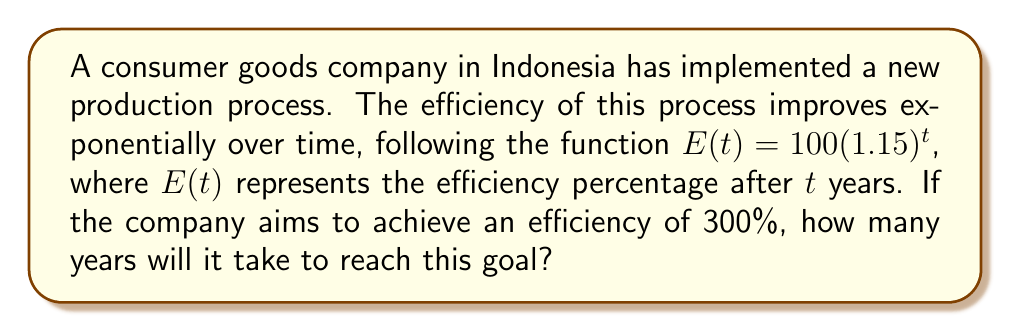Help me with this question. To solve this problem, we need to use the exponential function given and solve for $t$ when $E(t) = 300$. Let's approach this step-by-step:

1) We start with the equation: $E(t) = 100(1.15)^t$

2) We want to find $t$ when $E(t) = 300$, so we set up the equation:
   $300 = 100(1.15)^t$

3) Divide both sides by 100:
   $3 = (1.15)^t$

4) Take the natural logarithm of both sides:
   $\ln(3) = \ln((1.15)^t)$

5) Use the logarithm property $\ln(a^b) = b\ln(a)$:
   $\ln(3) = t\ln(1.15)$

6) Solve for $t$ by dividing both sides by $\ln(1.15)$:
   $t = \frac{\ln(3)}{\ln(1.15)}$

7) Calculate the value (you can use a calculator for this):
   $t \approx 7.85$ years

8) Since we're dealing with whole years, we need to round up to the next integer:
   $t = 8$ years

Therefore, it will take 8 years for the company to reach an efficiency of 300%.
Answer: 8 years 